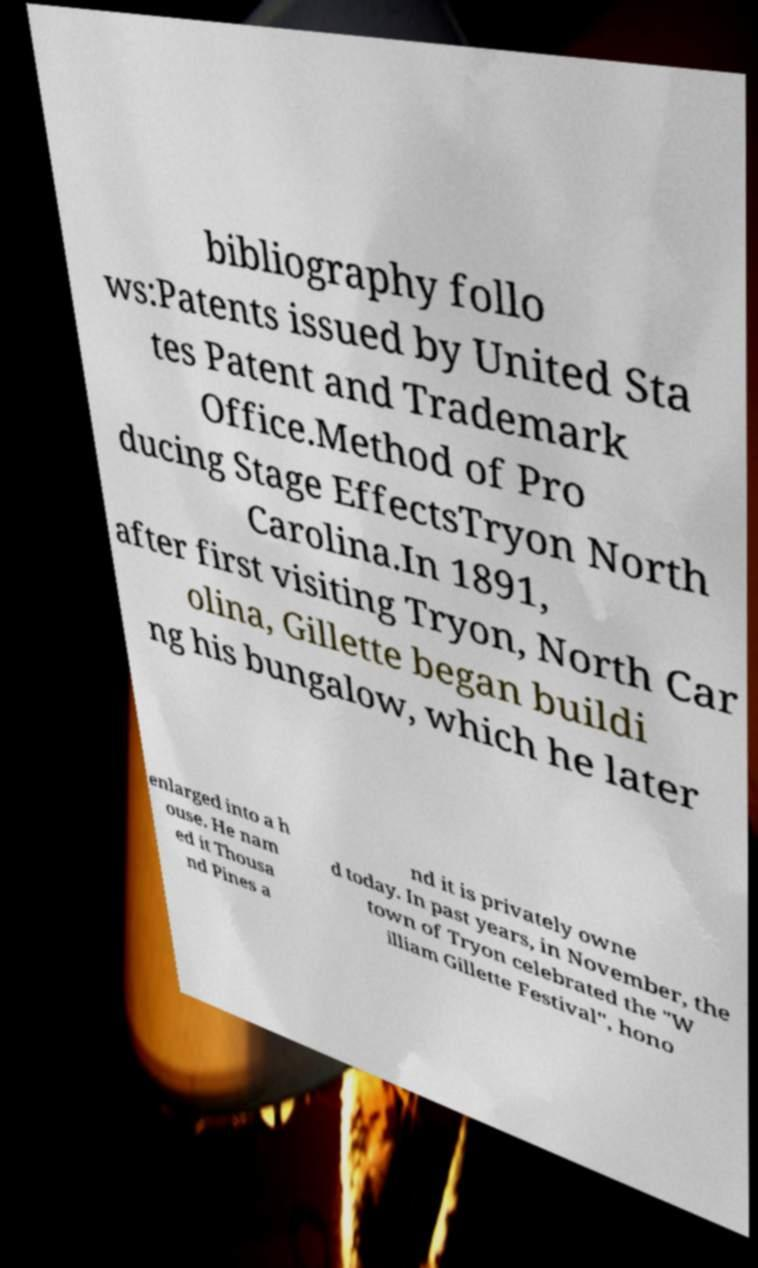I need the written content from this picture converted into text. Can you do that? bibliography follo ws:Patents issued by United Sta tes Patent and Trademark Office.Method of Pro ducing Stage EffectsTryon North Carolina.In 1891, after first visiting Tryon, North Car olina, Gillette began buildi ng his bungalow, which he later enlarged into a h ouse. He nam ed it Thousa nd Pines a nd it is privately owne d today. In past years, in November, the town of Tryon celebrated the "W illiam Gillette Festival", hono 